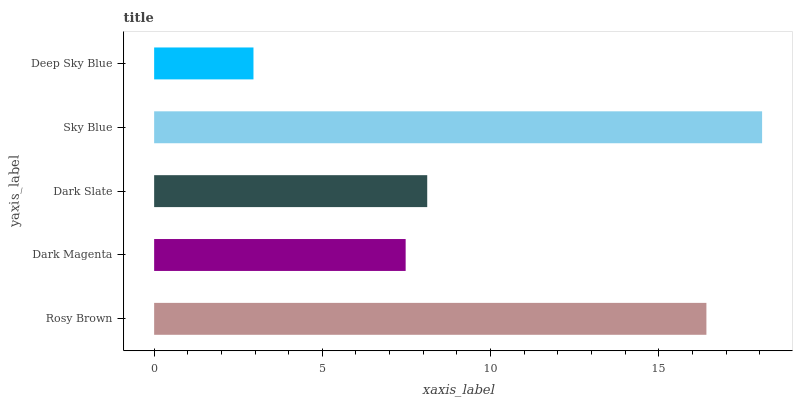Is Deep Sky Blue the minimum?
Answer yes or no. Yes. Is Sky Blue the maximum?
Answer yes or no. Yes. Is Dark Magenta the minimum?
Answer yes or no. No. Is Dark Magenta the maximum?
Answer yes or no. No. Is Rosy Brown greater than Dark Magenta?
Answer yes or no. Yes. Is Dark Magenta less than Rosy Brown?
Answer yes or no. Yes. Is Dark Magenta greater than Rosy Brown?
Answer yes or no. No. Is Rosy Brown less than Dark Magenta?
Answer yes or no. No. Is Dark Slate the high median?
Answer yes or no. Yes. Is Dark Slate the low median?
Answer yes or no. Yes. Is Dark Magenta the high median?
Answer yes or no. No. Is Rosy Brown the low median?
Answer yes or no. No. 